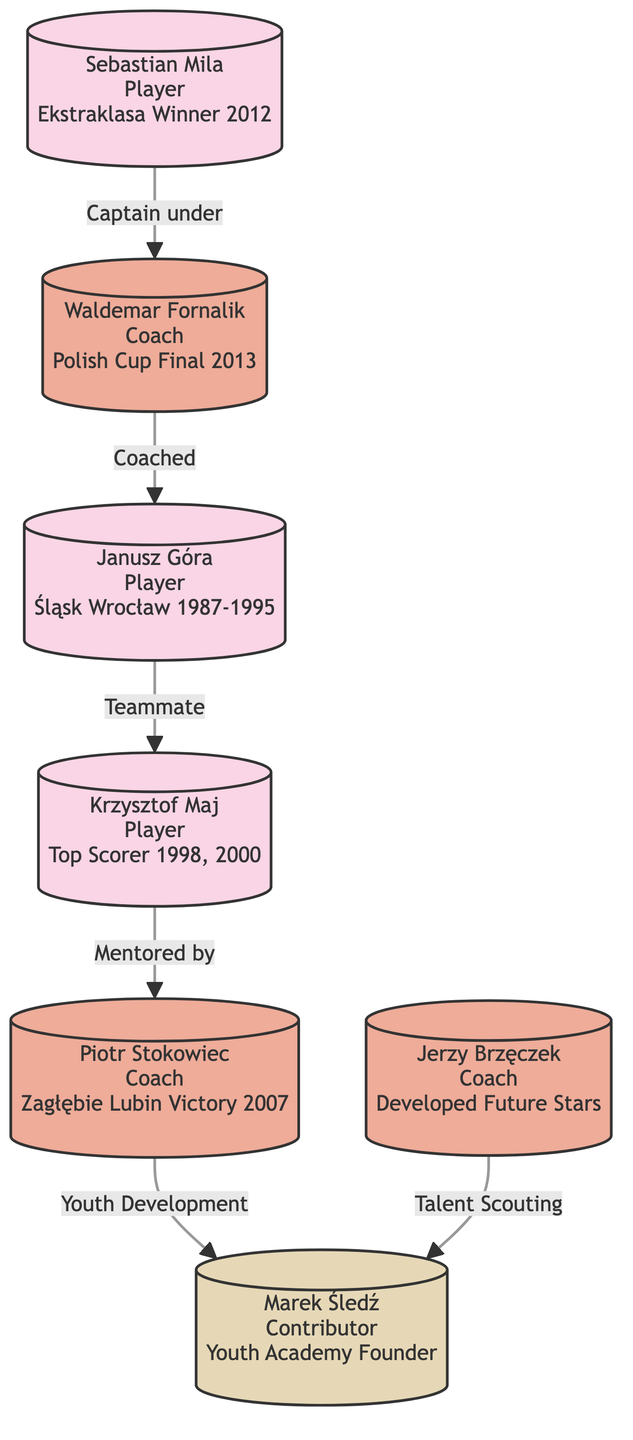What is the primary achievement of Krzysztof Maj? The diagram highlights that Krzysztof Maj is recognized as a Top Scorer in the years 1998 and 2000, indicating his significant contribution as a player during those seasons.
Answer: Top Scorer 1998, 2000 Who coached Janusz Góra? By examining the connections in the diagram, it shows that Janusz Góra was coached by Waldemar Fornalik, as indicated by the directed edge connecting the two.
Answer: Waldemar Fornalik How many players are depicted in the diagram? Counting the nodes labeled as players (Krzysztof Maj, Janusz Góra, and Sebastian Mila) gives us a total of three players in the diagram.
Answer: 3 What role does Marek Śledź hold in the football ecosystem shown in the diagram? The diagram categorizes Marek Śledź as a Contributor with the specific contribution of being the Youth Academy Founder, which outlines his involvement in developing future talent.
Answer: Contributor What connection exists between Sebastian Mila and Waldemar Fornalik? The diagram indicates that Sebastian Mila served as the Captain under Waldemar Fornalik, establishing a relationship based on leadership within the football team context.
Answer: Captain under Which coach is connected to talent scouting? By examining the arrows leading from the nodes, it is clear that Jerzy Brzęczek is the coach involved in talent scouting, as indicated by his connection to Marek Śledź, the Youth Academy Founder.
Answer: Jerzy Brzęczek How many total contributors are represented in the diagram? Assessing the diagram reveals that there is only one contributor node, which is Marek Śledź, identified as a Youth Academy Founder, thus totaling to one contributor.
Answer: 1 Which player has a direct mentor relationship with a coach? The diagram shows that Krzysztof Maj has a direct mentoring relationship with Piotr Stokowiec, highlighting an impactful connection between the player and the coach.
Answer: Piotr Stokowiec 